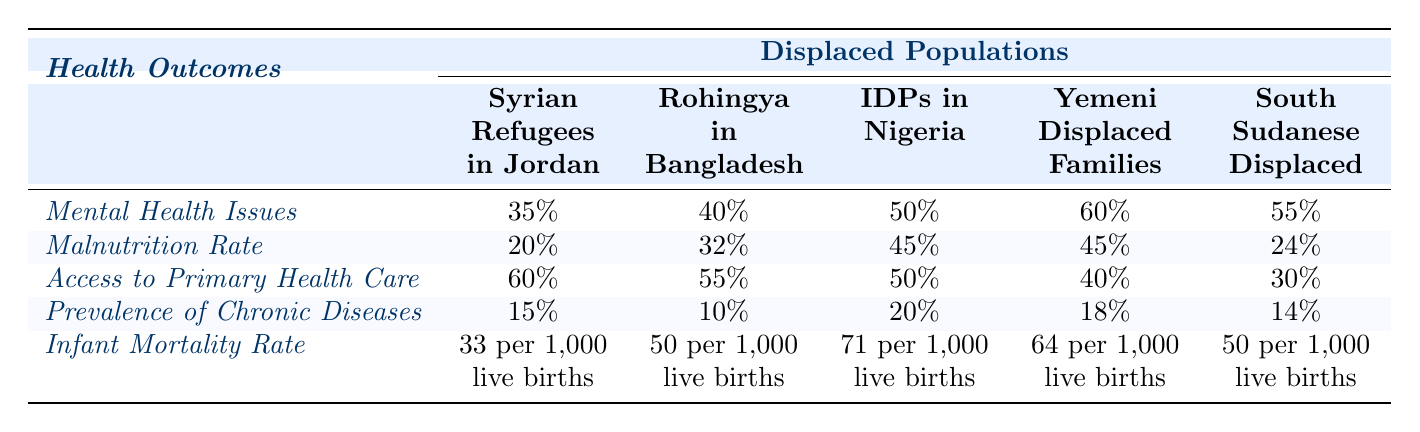What is the mental health issue percentage among Yemeni displaced families? According to the table, the mental health issues percentage for Yemeni displaced families is directly listed as 60%.
Answer: 60% Which displaced population has the highest malnutrition rate? To find the highest malnutrition rate, we compare the rates across all populations: Syrian Refugees (20%), Rohingya in Bangladesh (32%), IDPs in Nigeria (45%), Yemeni Displaced (45%), and South Sudanese (24%). The highest rates are both 45%, seen in IDPs in Nigeria and Yemeni Displaced Families.
Answer: IDPs in Nigeria and Yemeni Displaced Families (45%) How many populations have less than 50% access to primary health care? The populations with access percentages below 50% are Yemeni Displaced Families (40%) and South Sudanese Displaced (30%). Counting these, we see there are two populations with less than 50% access.
Answer: 2 What is the difference in infant mortality rate between the Syrian Refugees in Jordan and the Rohingya in Bangladesh? The infant mortality rate for Syrian Refugees is 33 per 1,000 live births, while for Rohingya it is 50 per 1,000 live births. The difference is calculated by subtracting: 50 - 33 = 17 per 1,000 live births.
Answer: 17 per 1,000 live births Which group has both the highest percentage of mental health issues and the highest prevalence of chronic diseases? Evaluating the table: Yemeni Displaced Families have the highest mental health issues at 60%, and for chronic diseases, the highest percentage is IDPs in Nigeria at 20%. No single group leads in both categories. Thus, no group has the highest in both.
Answer: No group What is the average malnutrition rate among the listed displaced populations? The malnutrition rates are 20%, 32%, 45%, 45%, and 24%. To calculate the average: (20 + 32 + 45 + 45 + 24) = 166. There are 5 populations, so the average is 166 / 5 = 33.2%.
Answer: 33.2% Is the access to primary health care for Syrian Refugees higher than that of South Sudanese Displaced populations? The access percentages are as follows: Syrian Refugees (60%) and South Sudanese (30%). Since 60% is greater than 30%, the statement is true.
Answer: Yes What can be inferred about the mental health issues in IDPs in Nigeria compared to Rohingya displaced community? The IDPs in Nigeria show mental health issues at 50%, while the Rohingya community has 40%. IDPs in Nigeria have a higher rate (50% > 40%) indicating worse mental health outcomes.
Answer: IDPs have worse mental health outcomes than Rohingya 